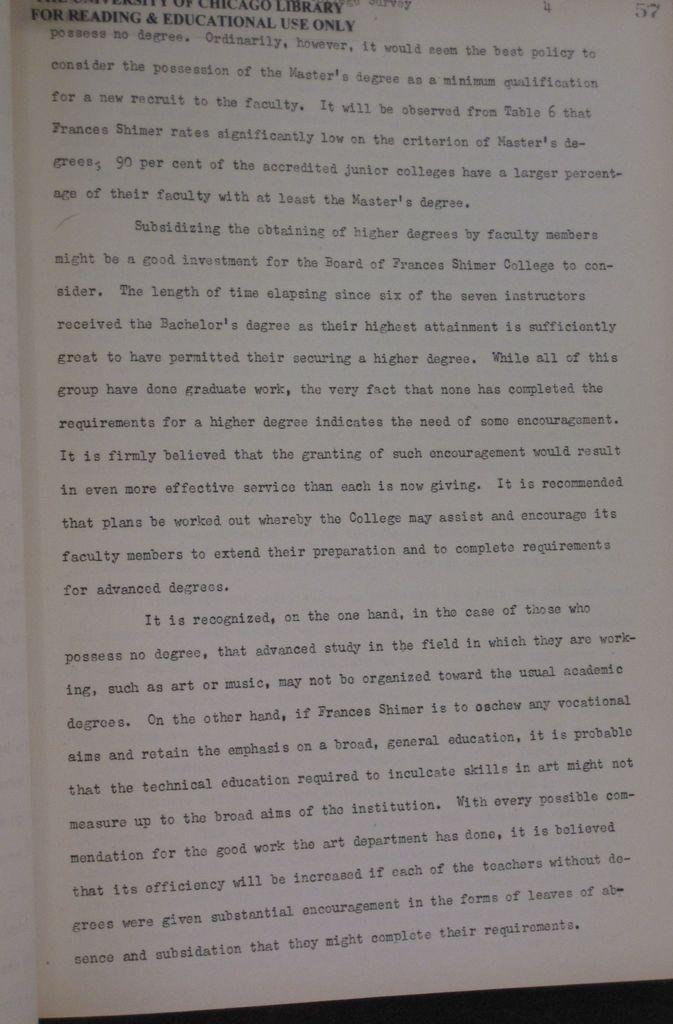Provide a one-sentence caption for the provided image. A paper for reading and education use only. 